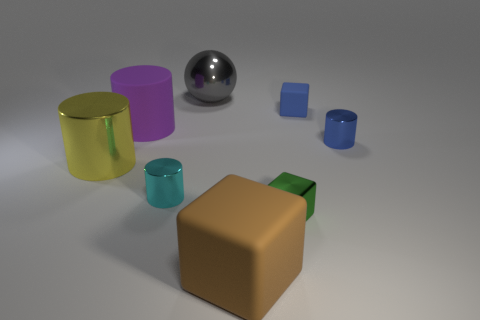Is there any other thing that is the same shape as the big gray thing?
Your answer should be very brief. No. How many cylinders are either cyan objects or large metallic objects?
Provide a succinct answer. 2. There is a big shiny ball that is on the left side of the big brown cube; what is its color?
Give a very brief answer. Gray. There is a matte thing that is the same size as the cyan cylinder; what is its shape?
Offer a very short reply. Cube. There is a small blue cylinder; what number of large things are behind it?
Make the answer very short. 2. How many objects are either green rubber cylinders or metal things?
Your answer should be very brief. 5. What shape is the rubber thing that is both to the right of the purple cylinder and to the left of the small blue block?
Your answer should be very brief. Cube. How many large brown blocks are there?
Ensure brevity in your answer.  1. What is the color of the large thing that is made of the same material as the big block?
Your answer should be compact. Purple. Is the number of yellow metal cylinders greater than the number of small yellow blocks?
Your answer should be very brief. Yes. 